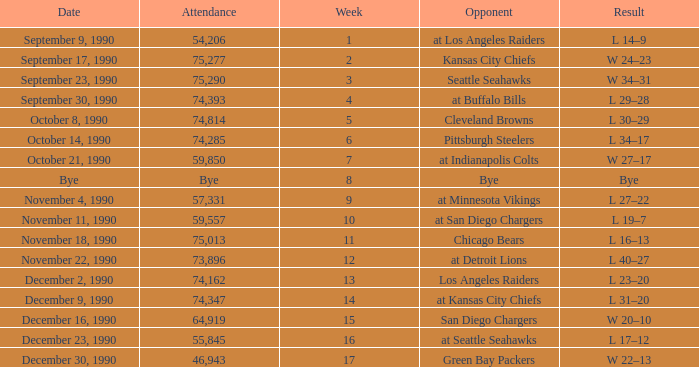What day was the attendance 74,285? October 14, 1990. 